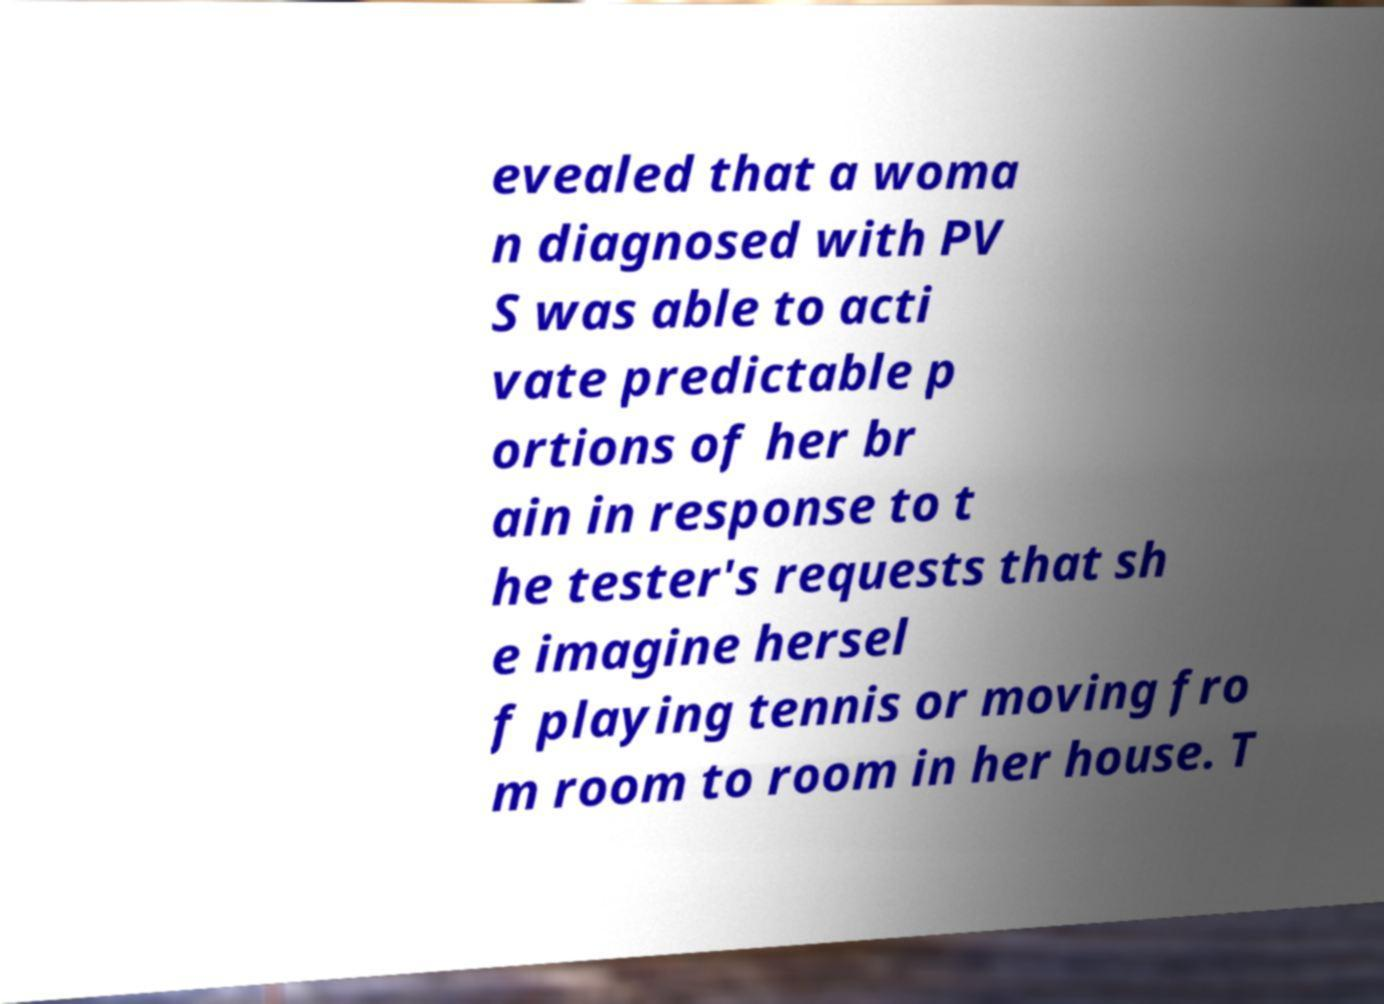For documentation purposes, I need the text within this image transcribed. Could you provide that? evealed that a woma n diagnosed with PV S was able to acti vate predictable p ortions of her br ain in response to t he tester's requests that sh e imagine hersel f playing tennis or moving fro m room to room in her house. T 